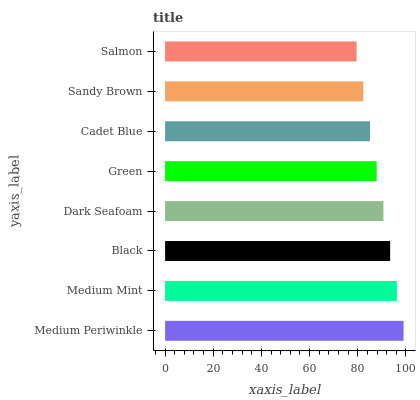Is Salmon the minimum?
Answer yes or no. Yes. Is Medium Periwinkle the maximum?
Answer yes or no. Yes. Is Medium Mint the minimum?
Answer yes or no. No. Is Medium Mint the maximum?
Answer yes or no. No. Is Medium Periwinkle greater than Medium Mint?
Answer yes or no. Yes. Is Medium Mint less than Medium Periwinkle?
Answer yes or no. Yes. Is Medium Mint greater than Medium Periwinkle?
Answer yes or no. No. Is Medium Periwinkle less than Medium Mint?
Answer yes or no. No. Is Dark Seafoam the high median?
Answer yes or no. Yes. Is Green the low median?
Answer yes or no. Yes. Is Medium Periwinkle the high median?
Answer yes or no. No. Is Dark Seafoam the low median?
Answer yes or no. No. 